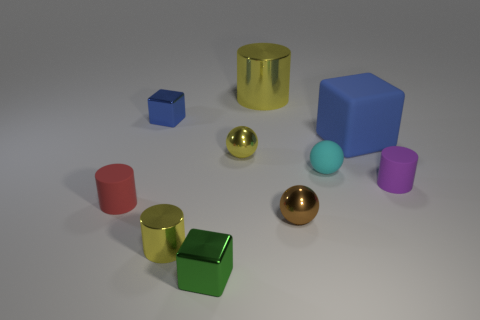Which objects in the image could be considered as having a reflective surface? The objects with reflective surfaces in the image include the gold and bronze colored spheres, as well as the yellow cylinder. These objects display visible reflections and highlights that suggest a shiny, metallic texture.  Are there any objects that stand out due to their size? Yes, the blue cube stands out as the largest object in the image. Its size is noticeably greater in comparison to all the other geometric shapes present. 